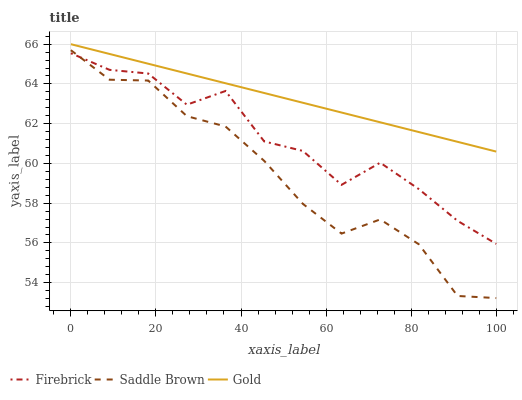Does Saddle Brown have the minimum area under the curve?
Answer yes or no. Yes. Does Gold have the maximum area under the curve?
Answer yes or no. Yes. Does Gold have the minimum area under the curve?
Answer yes or no. No. Does Saddle Brown have the maximum area under the curve?
Answer yes or no. No. Is Gold the smoothest?
Answer yes or no. Yes. Is Firebrick the roughest?
Answer yes or no. Yes. Is Saddle Brown the smoothest?
Answer yes or no. No. Is Saddle Brown the roughest?
Answer yes or no. No. Does Saddle Brown have the lowest value?
Answer yes or no. Yes. Does Gold have the lowest value?
Answer yes or no. No. Does Gold have the highest value?
Answer yes or no. Yes. Does Saddle Brown have the highest value?
Answer yes or no. No. Is Firebrick less than Gold?
Answer yes or no. Yes. Is Gold greater than Saddle Brown?
Answer yes or no. Yes. Does Firebrick intersect Saddle Brown?
Answer yes or no. Yes. Is Firebrick less than Saddle Brown?
Answer yes or no. No. Is Firebrick greater than Saddle Brown?
Answer yes or no. No. Does Firebrick intersect Gold?
Answer yes or no. No. 